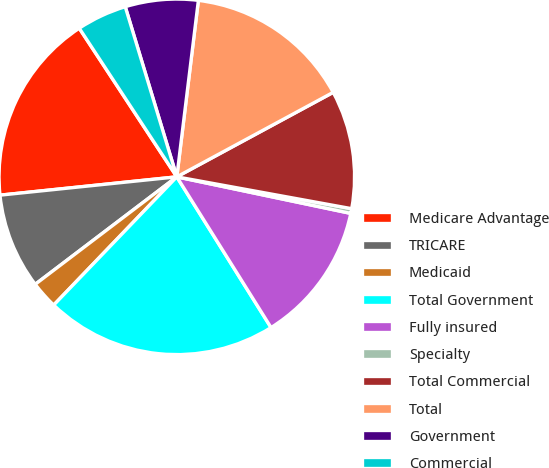Convert chart. <chart><loc_0><loc_0><loc_500><loc_500><pie_chart><fcel>Medicare Advantage<fcel>TRICARE<fcel>Medicaid<fcel>Total Government<fcel>Fully insured<fcel>Specialty<fcel>Total Commercial<fcel>Total<fcel>Government<fcel>Commercial<nl><fcel>17.4%<fcel>8.69%<fcel>2.49%<fcel>21.07%<fcel>12.81%<fcel>0.43%<fcel>10.75%<fcel>15.18%<fcel>6.62%<fcel>4.56%<nl></chart> 